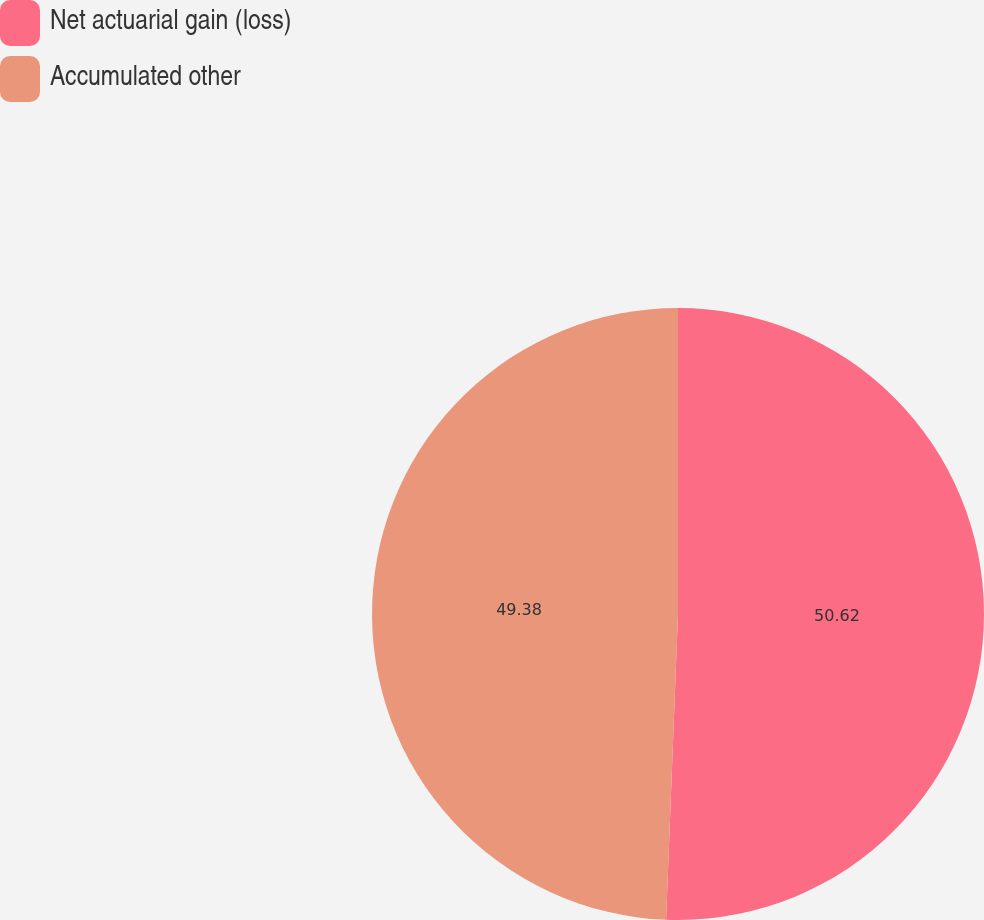Convert chart to OTSL. <chart><loc_0><loc_0><loc_500><loc_500><pie_chart><fcel>Net actuarial gain (loss)<fcel>Accumulated other<nl><fcel>50.62%<fcel>49.38%<nl></chart> 